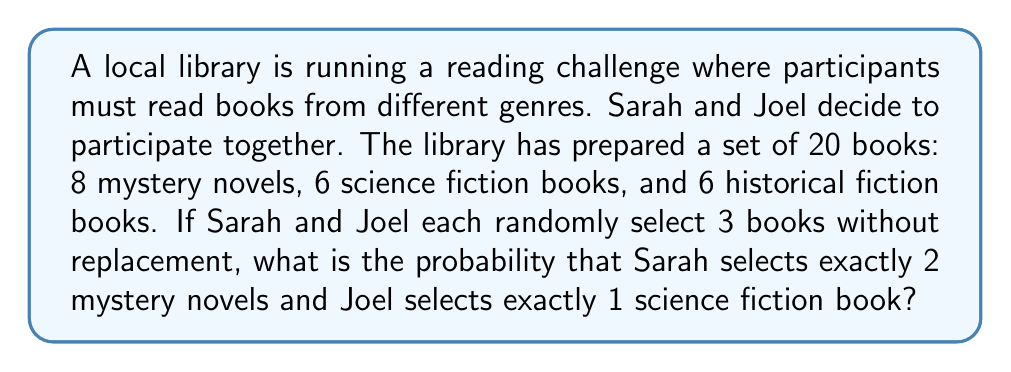Can you answer this question? Let's approach this step-by-step:

1) First, we need to calculate the probability of Sarah selecting exactly 2 mystery novels out of her 3 picks:

   a) There are $\binom{8}{2}$ ways to choose 2 mystery novels out of 8.
   b) There are $\binom{12}{1}$ ways to choose 1 non-mystery novel out of the remaining 12 books.
   c) The total number of ways to choose 3 books out of 20 is $\binom{20}{3}$.

   So, the probability for Sarah is:

   $$P(\text{Sarah}) = \frac{\binom{8}{2} \cdot \binom{12}{1}}{\binom{20}{3}}$$

2) Next, we calculate the probability of Joel selecting exactly 1 science fiction book out of his 3 picks, given that Sarah has already selected her books:

   a) There are $\binom{6}{1}$ ways to choose 1 science fiction book out of the remaining 6.
   b) There are $\binom{11}{2}$ ways to choose 2 non-science fiction books out of the remaining 11 books (17 total - 6 science fiction).
   c) The total number of ways to choose 3 books out of the remaining 17 is $\binom{17}{3}$.

   So, the probability for Joel is:

   $$P(\text{Joel}) = \frac{\binom{6}{1} \cdot \binom{11}{2}}{\binom{17}{3}}$$

3) The probability of both events occurring is the product of their individual probabilities:

   $$P(\text{Sarah and Joel}) = P(\text{Sarah}) \cdot P(\text{Joel})$$

4) Calculating the values:

   $$P(\text{Sarah}) = \frac{\binom{8}{2} \cdot \binom{12}{1}}{\binom{20}{3}} = \frac{28 \cdot 12}{1140} = \frac{336}{1140}$$

   $$P(\text{Joel}) = \frac{\binom{6}{1} \cdot \binom{11}{2}}{\binom{17}{3}} = \frac{6 \cdot 55}{680} = \frac{330}{680}$$

   $$P(\text{Sarah and Joel}) = \frac{336}{1140} \cdot \frac{330}{680} = \frac{110880}{775200} = \frac{693}{4845} \approx 0.1431$$
Answer: $\frac{693}{4845}$ 